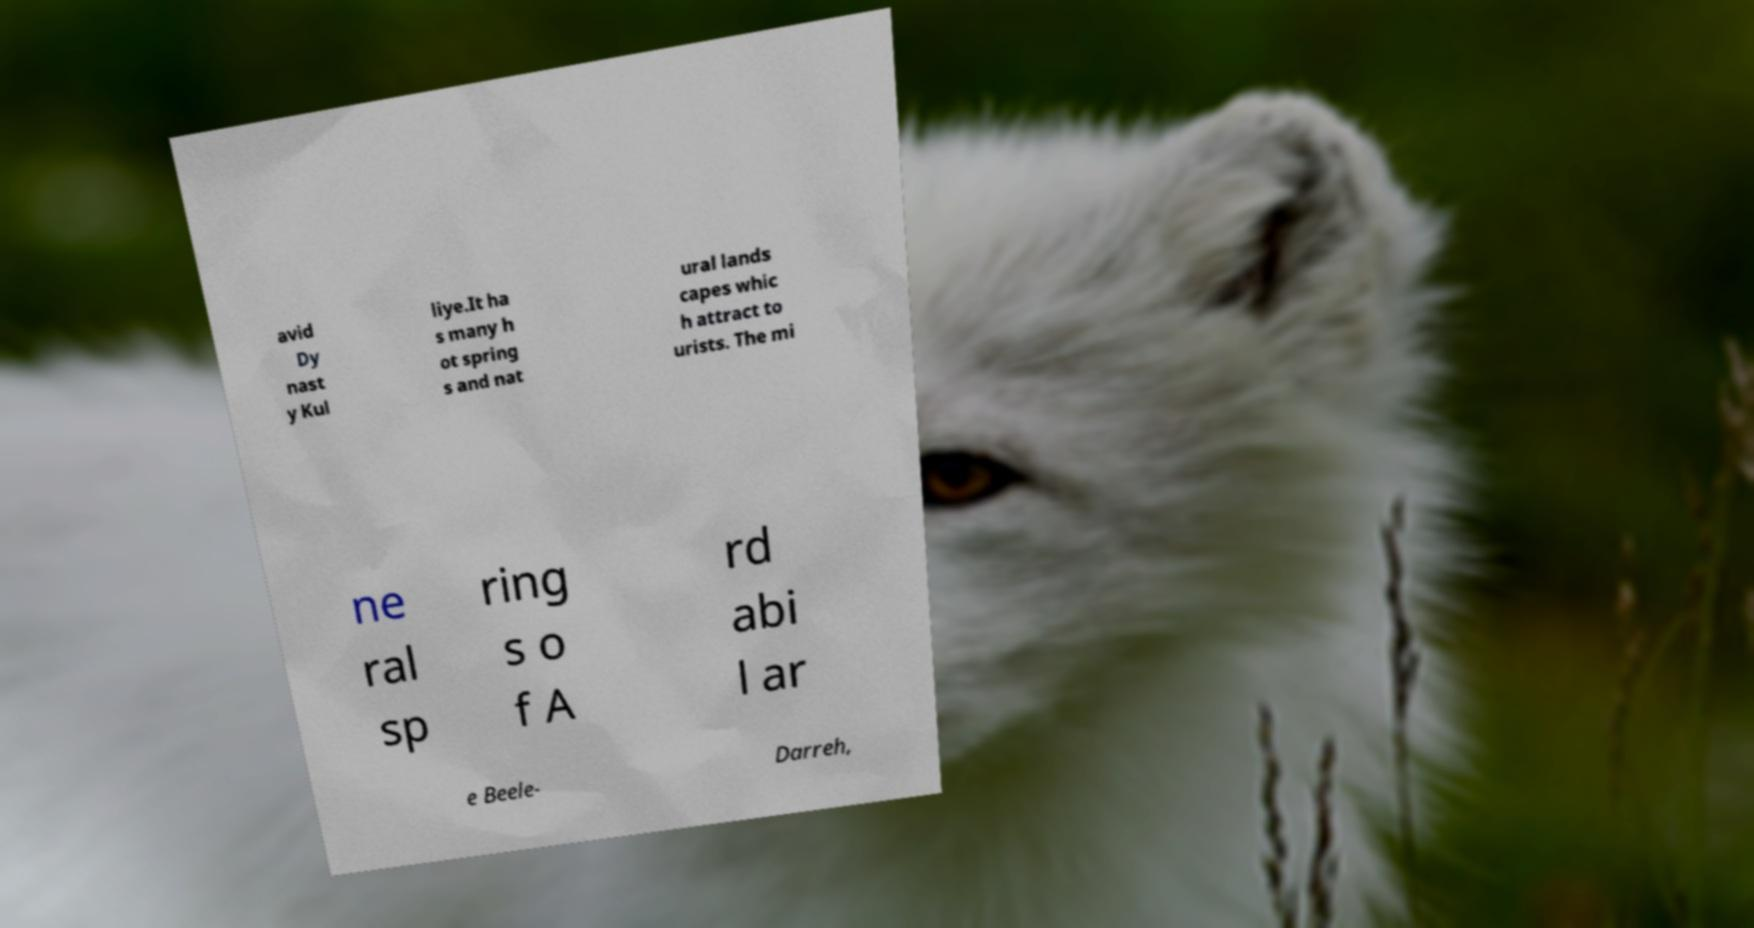Can you accurately transcribe the text from the provided image for me? avid Dy nast y Kul liye.It ha s many h ot spring s and nat ural lands capes whic h attract to urists. The mi ne ral sp ring s o f A rd abi l ar e Beele- Darreh, 